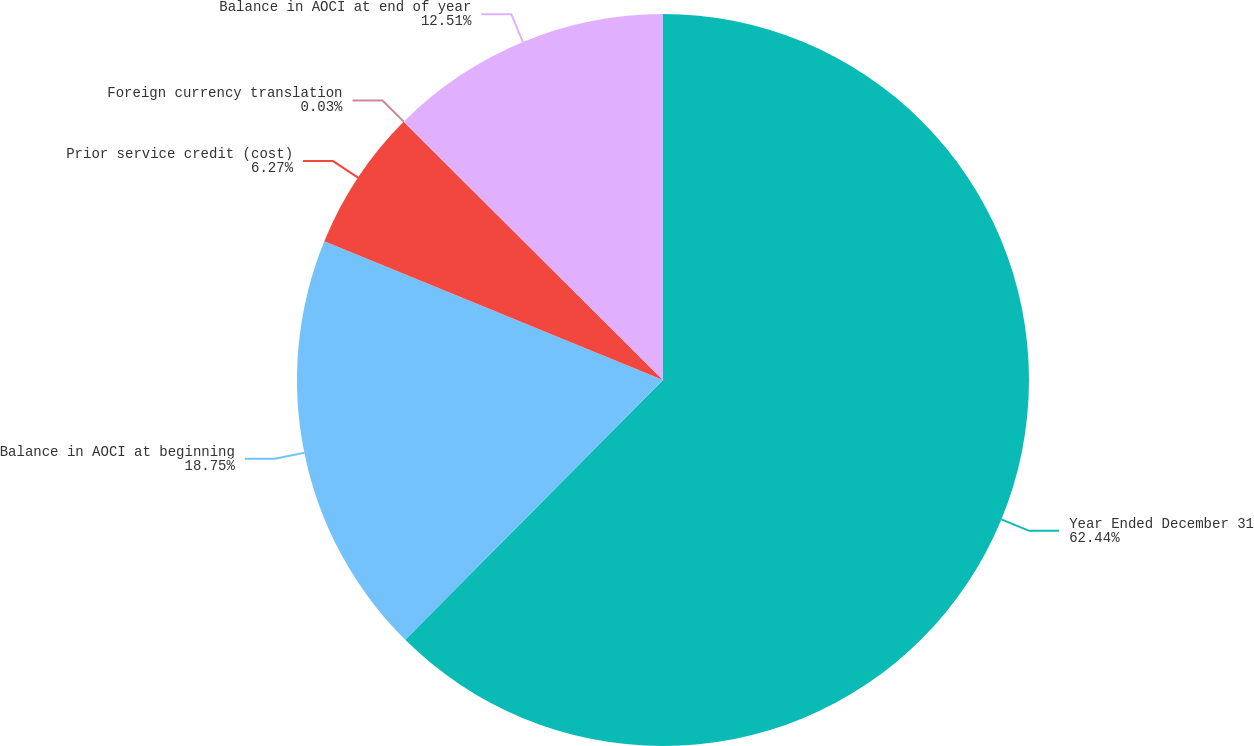Convert chart to OTSL. <chart><loc_0><loc_0><loc_500><loc_500><pie_chart><fcel>Year Ended December 31<fcel>Balance in AOCI at beginning<fcel>Prior service credit (cost)<fcel>Foreign currency translation<fcel>Balance in AOCI at end of year<nl><fcel>62.43%<fcel>18.75%<fcel>6.27%<fcel>0.03%<fcel>12.51%<nl></chart> 